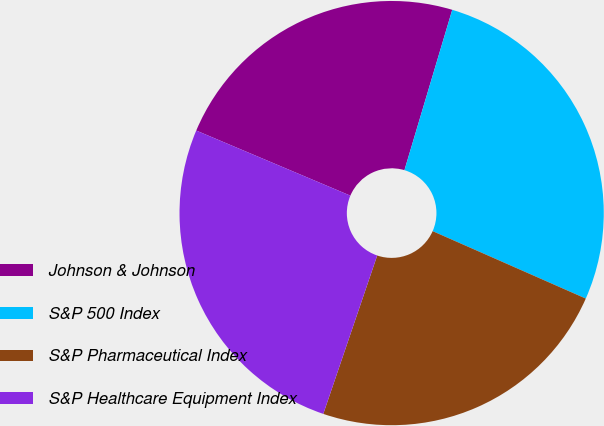Convert chart to OTSL. <chart><loc_0><loc_0><loc_500><loc_500><pie_chart><fcel>Johnson & Johnson<fcel>S&P 500 Index<fcel>S&P Pharmaceutical Index<fcel>S&P Healthcare Equipment Index<nl><fcel>23.25%<fcel>26.99%<fcel>23.62%<fcel>26.14%<nl></chart> 